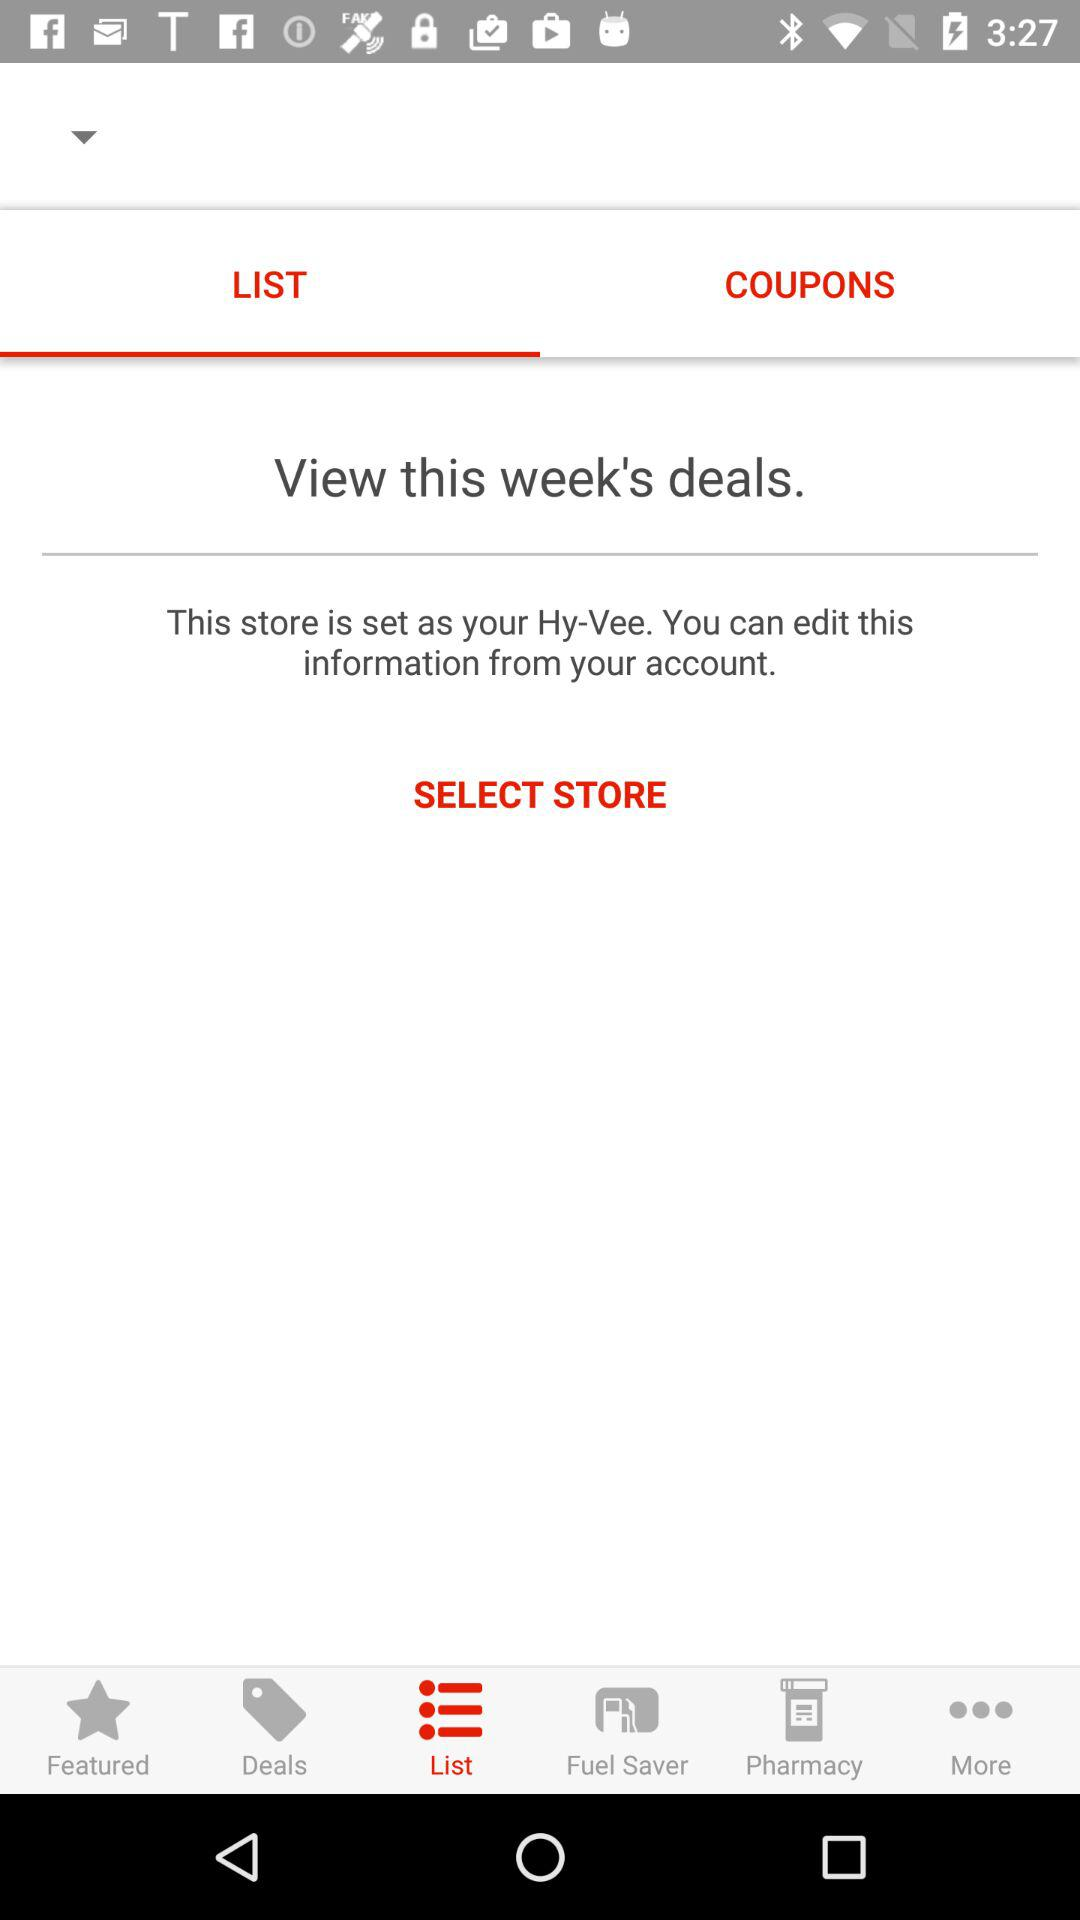What's the period of the deals?
When the provided information is insufficient, respond with <no answer>. <no answer> 